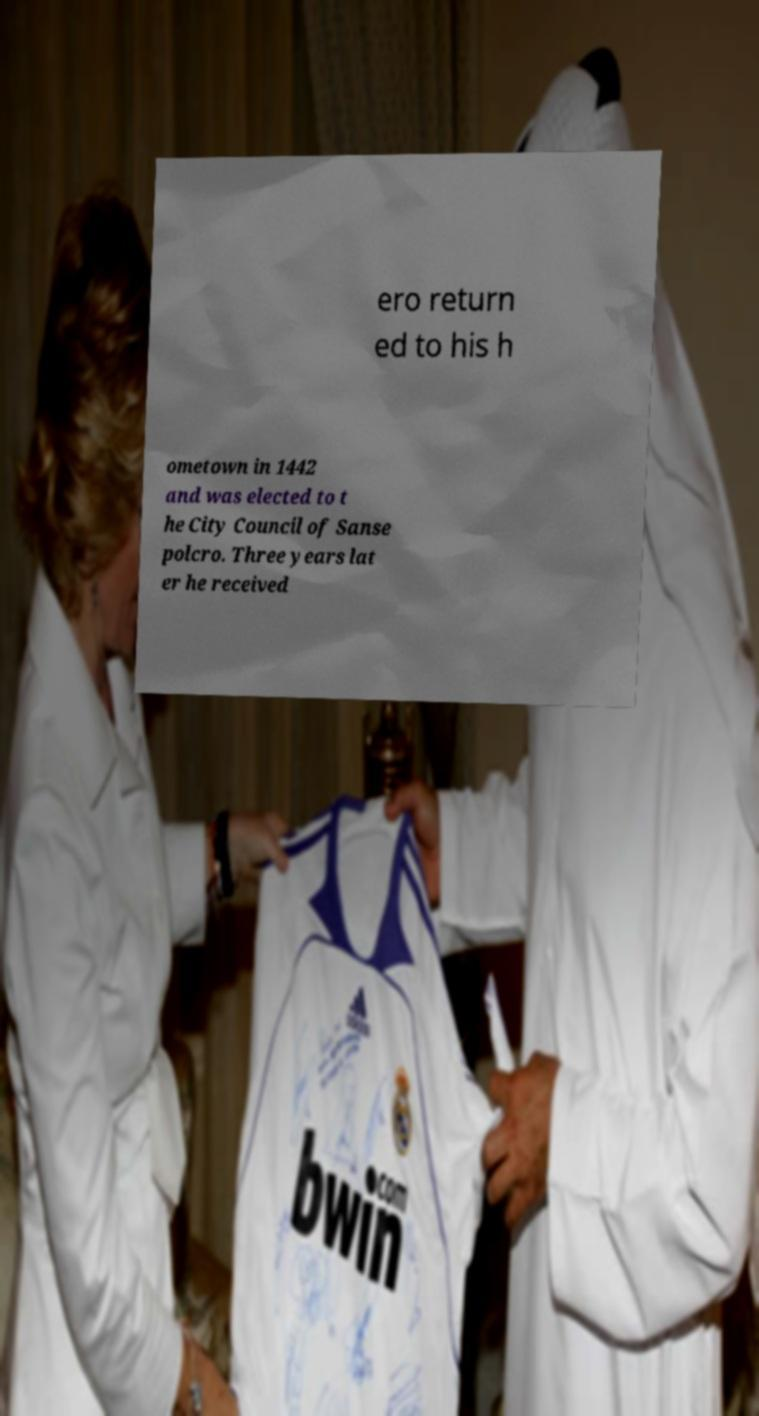Can you accurately transcribe the text from the provided image for me? ero return ed to his h ometown in 1442 and was elected to t he City Council of Sanse polcro. Three years lat er he received 